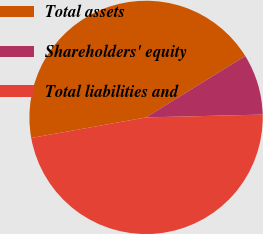<chart> <loc_0><loc_0><loc_500><loc_500><pie_chart><fcel>Total assets<fcel>Shareholders' equity<fcel>Total liabilities and<nl><fcel>44.0%<fcel>8.44%<fcel>47.56%<nl></chart> 